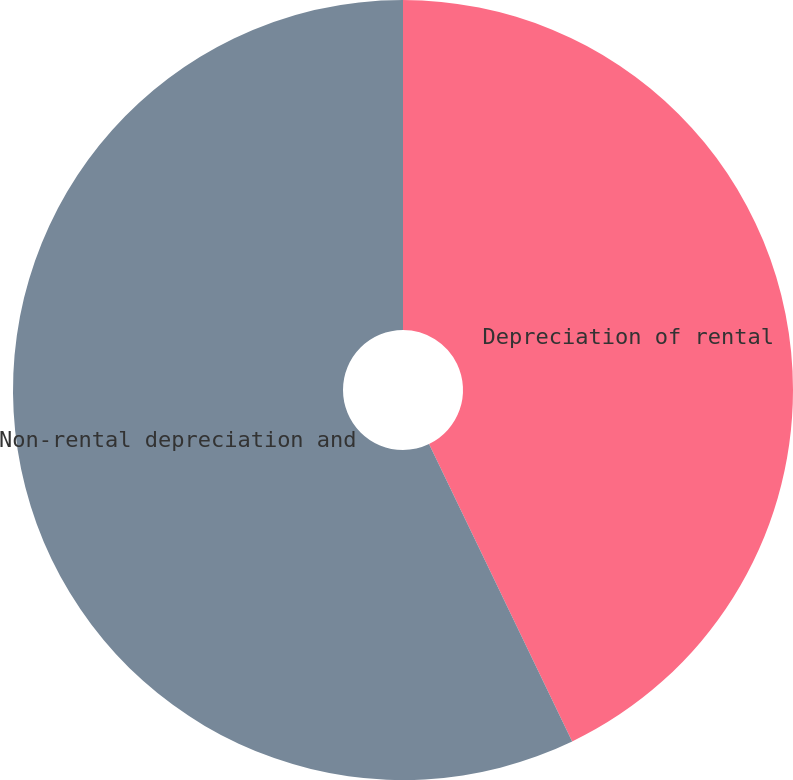Convert chart to OTSL. <chart><loc_0><loc_0><loc_500><loc_500><pie_chart><fcel>Depreciation of rental<fcel>Non-rental depreciation and<nl><fcel>42.86%<fcel>57.14%<nl></chart> 